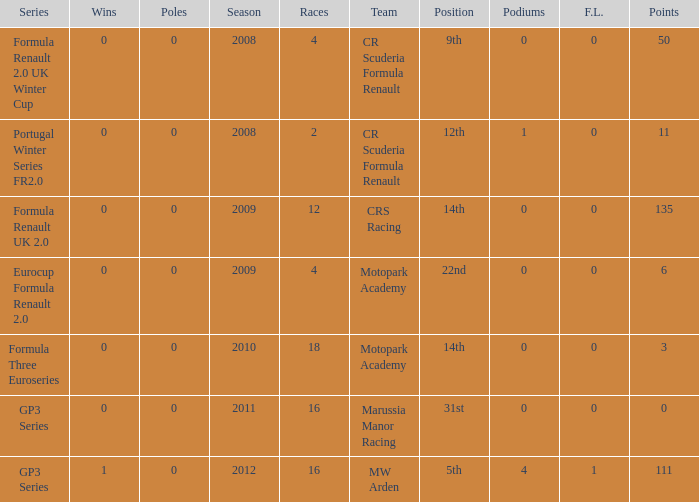What are the most poles listed? 0.0. 